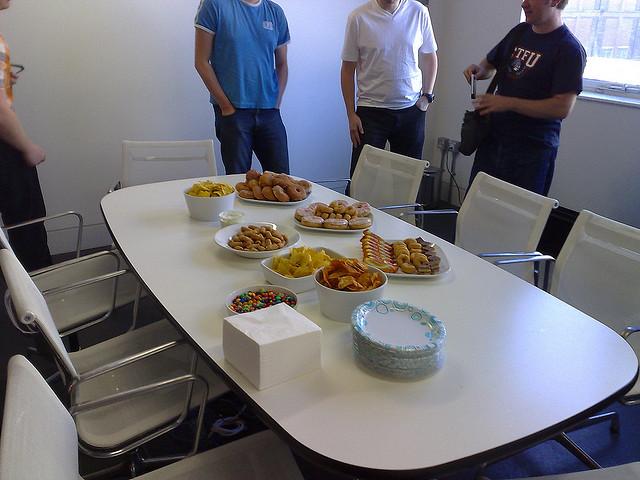How many seats are occupied?
Short answer required. 0. How many bowls are filled with candy?
Keep it brief. 1. How many people are in the room?
Short answer required. 4. 